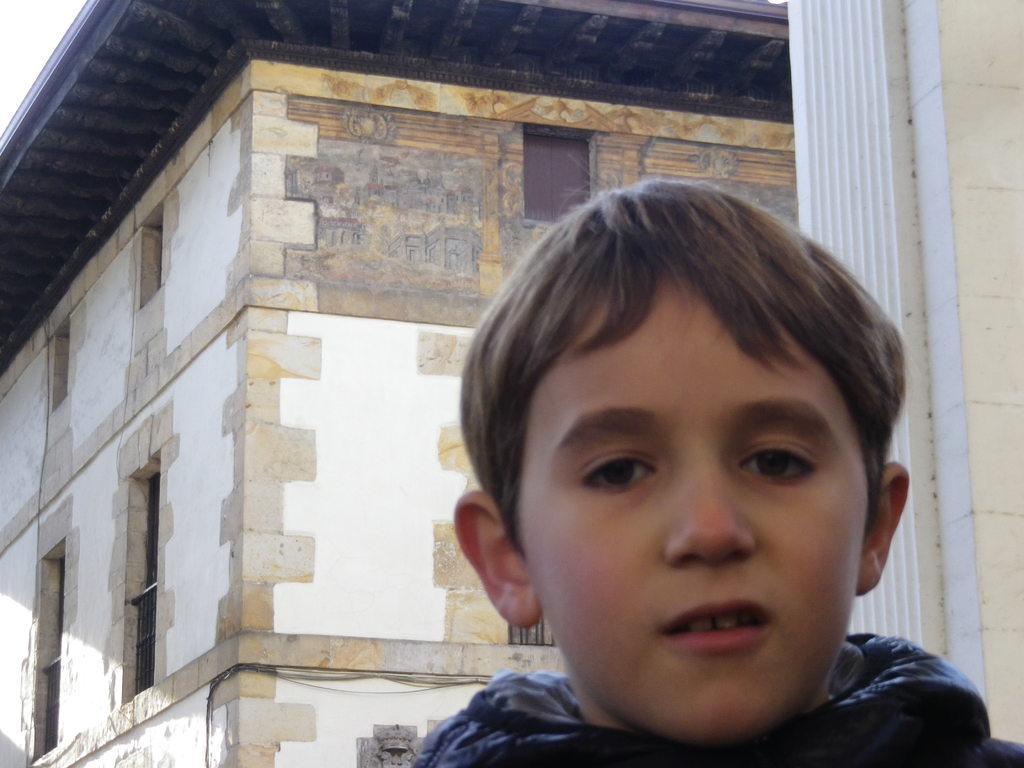Could you give a brief overview of what you see in this image? In this image I can see a person and the person is wearing black color jacket. Background I can see the building in white and cream color and the sky is in white color. 